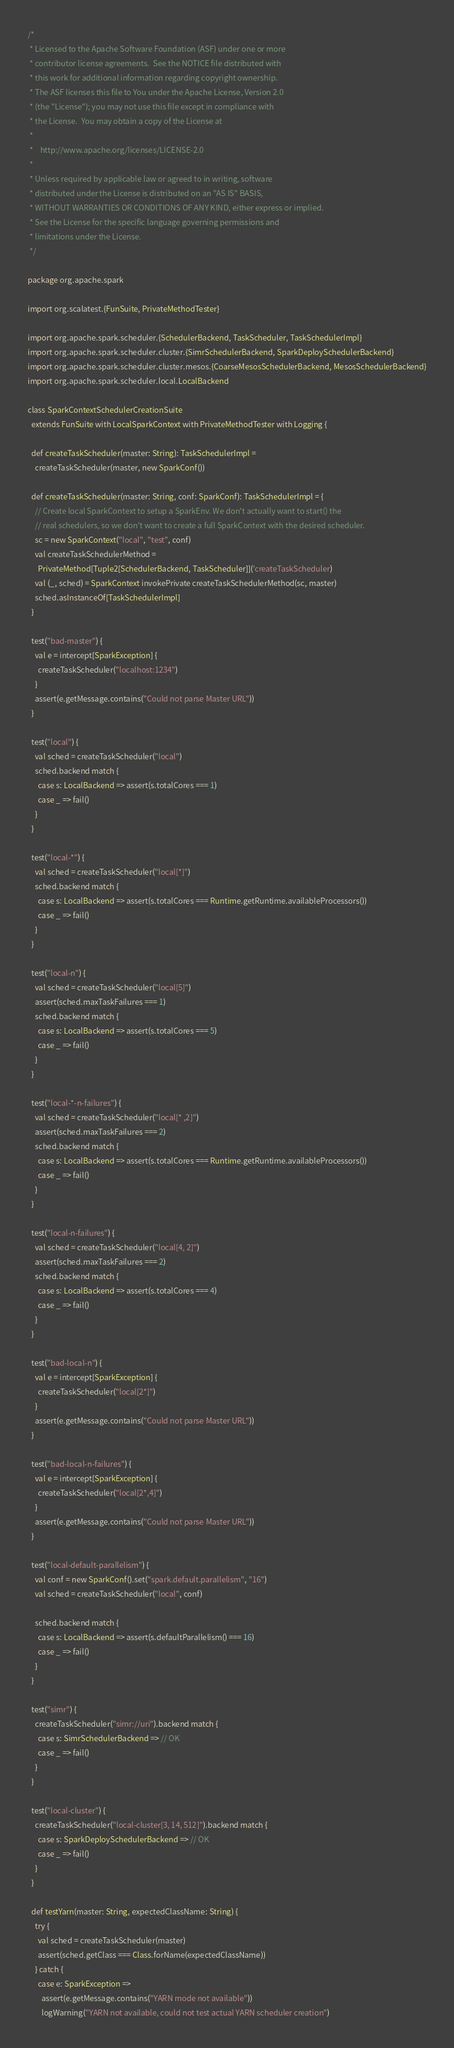Convert code to text. <code><loc_0><loc_0><loc_500><loc_500><_Scala_>/*
 * Licensed to the Apache Software Foundation (ASF) under one or more
 * contributor license agreements.  See the NOTICE file distributed with
 * this work for additional information regarding copyright ownership.
 * The ASF licenses this file to You under the Apache License, Version 2.0
 * (the "License"); you may not use this file except in compliance with
 * the License.  You may obtain a copy of the License at
 *
 *    http://www.apache.org/licenses/LICENSE-2.0
 *
 * Unless required by applicable law or agreed to in writing, software
 * distributed under the License is distributed on an "AS IS" BASIS,
 * WITHOUT WARRANTIES OR CONDITIONS OF ANY KIND, either express or implied.
 * See the License for the specific language governing permissions and
 * limitations under the License.
 */

package org.apache.spark

import org.scalatest.{FunSuite, PrivateMethodTester}

import org.apache.spark.scheduler.{SchedulerBackend, TaskScheduler, TaskSchedulerImpl}
import org.apache.spark.scheduler.cluster.{SimrSchedulerBackend, SparkDeploySchedulerBackend}
import org.apache.spark.scheduler.cluster.mesos.{CoarseMesosSchedulerBackend, MesosSchedulerBackend}
import org.apache.spark.scheduler.local.LocalBackend

class SparkContextSchedulerCreationSuite
  extends FunSuite with LocalSparkContext with PrivateMethodTester with Logging {

  def createTaskScheduler(master: String): TaskSchedulerImpl =
    createTaskScheduler(master, new SparkConf())

  def createTaskScheduler(master: String, conf: SparkConf): TaskSchedulerImpl = {
    // Create local SparkContext to setup a SparkEnv. We don't actually want to start() the
    // real schedulers, so we don't want to create a full SparkContext with the desired scheduler.
    sc = new SparkContext("local", "test", conf)
    val createTaskSchedulerMethod =
      PrivateMethod[Tuple2[SchedulerBackend, TaskScheduler]]('createTaskScheduler)
    val (_, sched) = SparkContext invokePrivate createTaskSchedulerMethod(sc, master)
    sched.asInstanceOf[TaskSchedulerImpl]
  }

  test("bad-master") {
    val e = intercept[SparkException] {
      createTaskScheduler("localhost:1234")
    }
    assert(e.getMessage.contains("Could not parse Master URL"))
  }

  test("local") {
    val sched = createTaskScheduler("local")
    sched.backend match {
      case s: LocalBackend => assert(s.totalCores === 1)
      case _ => fail()
    }
  }

  test("local-*") {
    val sched = createTaskScheduler("local[*]")
    sched.backend match {
      case s: LocalBackend => assert(s.totalCores === Runtime.getRuntime.availableProcessors())
      case _ => fail()
    }
  }

  test("local-n") {
    val sched = createTaskScheduler("local[5]")
    assert(sched.maxTaskFailures === 1)
    sched.backend match {
      case s: LocalBackend => assert(s.totalCores === 5)
      case _ => fail()
    }
  }

  test("local-*-n-failures") {
    val sched = createTaskScheduler("local[* ,2]")
    assert(sched.maxTaskFailures === 2)
    sched.backend match {
      case s: LocalBackend => assert(s.totalCores === Runtime.getRuntime.availableProcessors())
      case _ => fail()
    }
  }

  test("local-n-failures") {
    val sched = createTaskScheduler("local[4, 2]")
    assert(sched.maxTaskFailures === 2)
    sched.backend match {
      case s: LocalBackend => assert(s.totalCores === 4)
      case _ => fail()
    }
  }

  test("bad-local-n") {
    val e = intercept[SparkException] {
      createTaskScheduler("local[2*]")
    }
    assert(e.getMessage.contains("Could not parse Master URL"))
  }

  test("bad-local-n-failures") {
    val e = intercept[SparkException] {
      createTaskScheduler("local[2*,4]")
    }
    assert(e.getMessage.contains("Could not parse Master URL"))
  }

  test("local-default-parallelism") {
    val conf = new SparkConf().set("spark.default.parallelism", "16")
    val sched = createTaskScheduler("local", conf)

    sched.backend match {
      case s: LocalBackend => assert(s.defaultParallelism() === 16)
      case _ => fail()
    }
  }

  test("simr") {
    createTaskScheduler("simr://uri").backend match {
      case s: SimrSchedulerBackend => // OK
      case _ => fail()
    }
  }

  test("local-cluster") {
    createTaskScheduler("local-cluster[3, 14, 512]").backend match {
      case s: SparkDeploySchedulerBackend => // OK
      case _ => fail()
    }
  }

  def testYarn(master: String, expectedClassName: String) {
    try {
      val sched = createTaskScheduler(master)
      assert(sched.getClass === Class.forName(expectedClassName))
    } catch {
      case e: SparkException =>
        assert(e.getMessage.contains("YARN mode not available"))
        logWarning("YARN not available, could not test actual YARN scheduler creation")</code> 